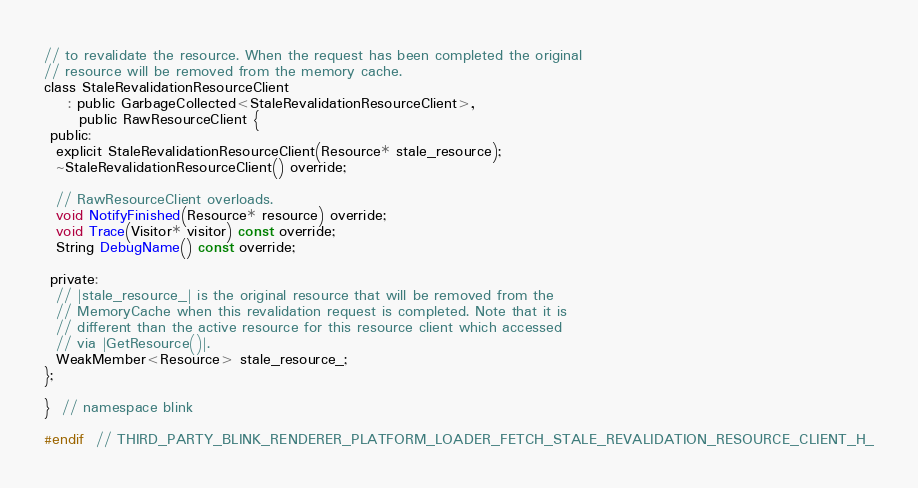<code> <loc_0><loc_0><loc_500><loc_500><_C_>// to revalidate the resource. When the request has been completed the original
// resource will be removed from the memory cache.
class StaleRevalidationResourceClient
    : public GarbageCollected<StaleRevalidationResourceClient>,
      public RawResourceClient {
 public:
  explicit StaleRevalidationResourceClient(Resource* stale_resource);
  ~StaleRevalidationResourceClient() override;

  // RawResourceClient overloads.
  void NotifyFinished(Resource* resource) override;
  void Trace(Visitor* visitor) const override;
  String DebugName() const override;

 private:
  // |stale_resource_| is the original resource that will be removed from the
  // MemoryCache when this revalidation request is completed. Note that it is
  // different than the active resource for this resource client which accessed
  // via |GetResource()|.
  WeakMember<Resource> stale_resource_;
};

}  // namespace blink

#endif  // THIRD_PARTY_BLINK_RENDERER_PLATFORM_LOADER_FETCH_STALE_REVALIDATION_RESOURCE_CLIENT_H_
</code> 